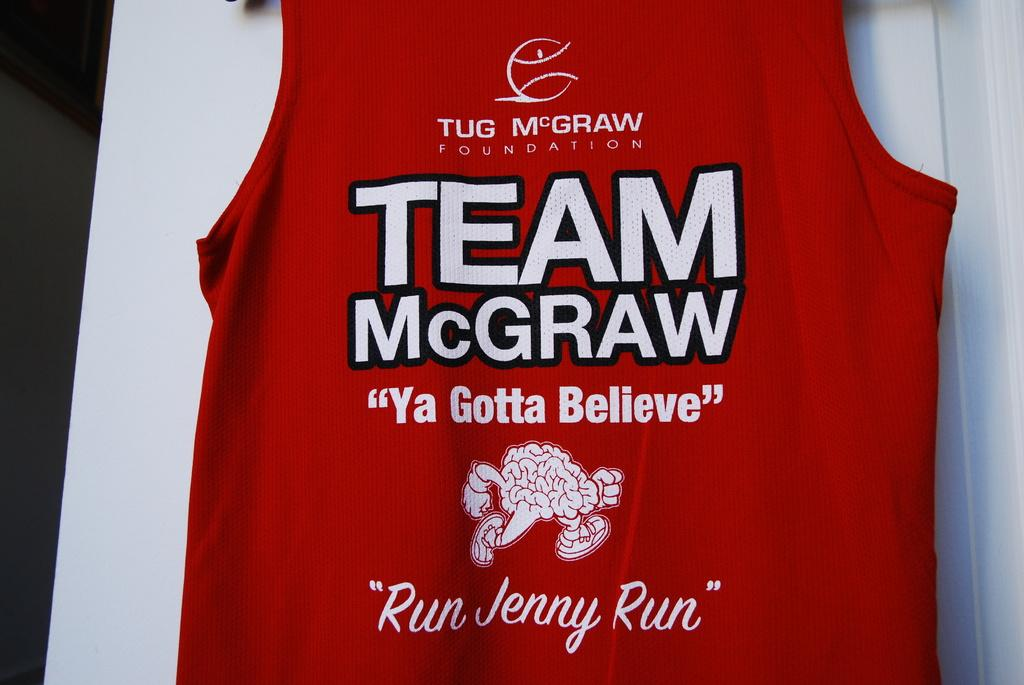<image>
Provide a brief description of the given image. A red Team McGraw jersey sits against a white background 